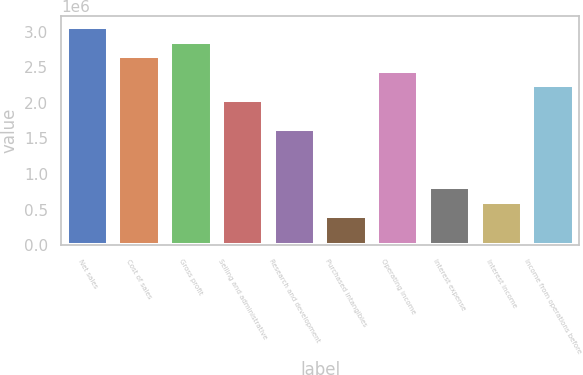Convert chart. <chart><loc_0><loc_0><loc_500><loc_500><bar_chart><fcel>Net sales<fcel>Cost of sales<fcel>Gross profit<fcel>Selling and administrative<fcel>Research and development<fcel>Purchased intangibles<fcel>Operating income<fcel>Interest expense<fcel>Interest income<fcel>Income from operations before<nl><fcel>3.0635e+06<fcel>2.65503e+06<fcel>2.85926e+06<fcel>2.04233e+06<fcel>1.63387e+06<fcel>408471<fcel>2.4508e+06<fcel>816936<fcel>612704<fcel>2.24656e+06<nl></chart> 